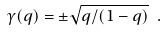<formula> <loc_0><loc_0><loc_500><loc_500>\gamma ( q ) = \pm \sqrt { q / ( 1 - q ) } \ .</formula> 